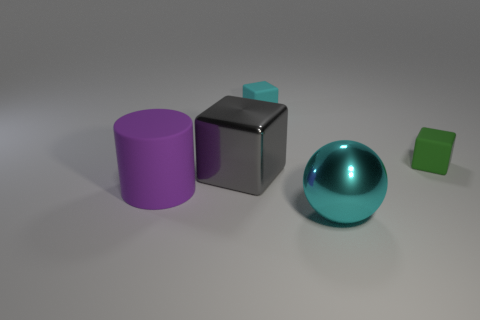Add 1 large gray metallic cubes. How many objects exist? 6 Subtract all cylinders. How many objects are left? 4 Subtract 0 brown blocks. How many objects are left? 5 Subtract all yellow cylinders. Subtract all spheres. How many objects are left? 4 Add 4 metallic objects. How many metallic objects are left? 6 Add 1 brown metal cubes. How many brown metal cubes exist? 1 